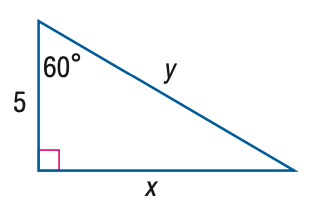Question: Find y.
Choices:
A. 5
B. 5 \sqrt { 2 }
C. 5 \sqrt { 3 }
D. 10
Answer with the letter. Answer: D Question: Find x.
Choices:
A. \frac { 5 } { 3 } \sqrt { 3 }
B. 5
C. 5 \sqrt { 3 }
D. 10
Answer with the letter. Answer: C 